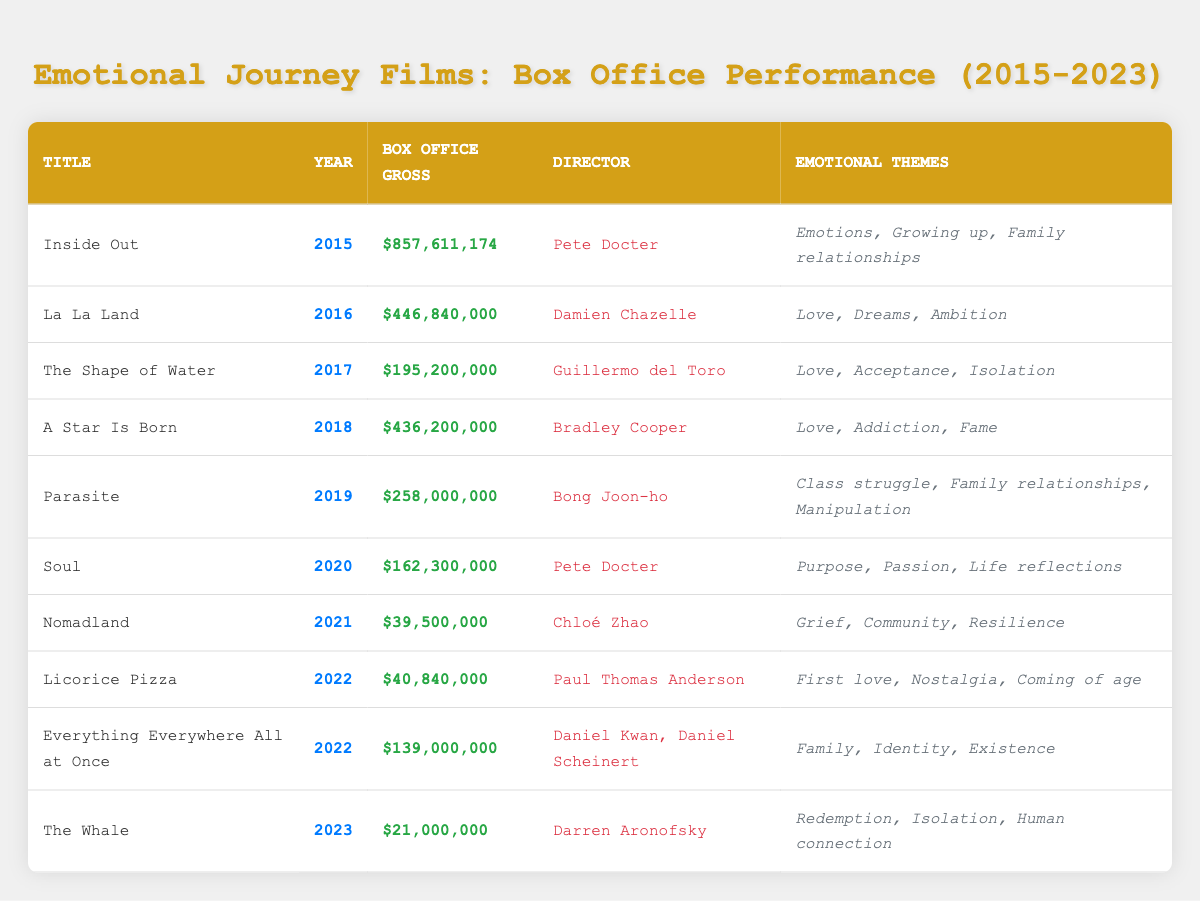What film released in 2015 had the highest box office gross? The table shows "Inside Out" as the only film released in 2015. Its box office gross is $857,611,174, which is the highest among all films listed.
Answer: Inside Out Which director worked on both "Inside Out" and "Soul"? By checking the director column, it shows that both films were directed by Pete Docter.
Answer: Pete Docter What is the total box office gross of the films released in 2022? The films released in 2022 are "Licorice Pizza" with a gross of $40,840,000 and "Everything Everywhere All at Once" with a gross of $139,000,000. Adding these together: $40,840,000 + $139,000,000 = $179,840,000.
Answer: $179,840,000 Was "Nomadland" more commercially successful than "The Whale"? "Nomadland" grossed $39,500,000 while "The Whale" grossed $21,000,000. Since $39,500,000 is greater than $21,000,000, "Nomadland" was more successful.
Answer: Yes Which film features themes of family relationships and was released in 2019? By checking the emotional themes of the films, "Parasite" released in 2019 includes "Family relationships" among its themes.
Answer: Parasite What is the average box office gross of the films directed by Chloé Zhao? "Nomadland" is the only film by Chloé Zhao in the table, with a gross of $39,500,000. Therefore, the average is $39,500,000 since there is only one film.
Answer: $39,500,000 What emotional theme is common to both "A Star Is Born" and "The Shape of Water"? Looking at the themes, both films include "Love." Thus, that is a common emotional theme between them.
Answer: Love Which film had a box office gross less than $50 million? Referring to the table, both "Nomadland" and "The Whale" had grosses of $39,500,000 and $21,000,000 respectively, both of which are under $50 million.
Answer: Nomadland, The Whale In what year was the film with the lowest box office gross released? The film with the lowest box office gross is "The Whale," released in 2023, which grossed $21,000,000. Therefore, 2023 is the correct year.
Answer: 2023 